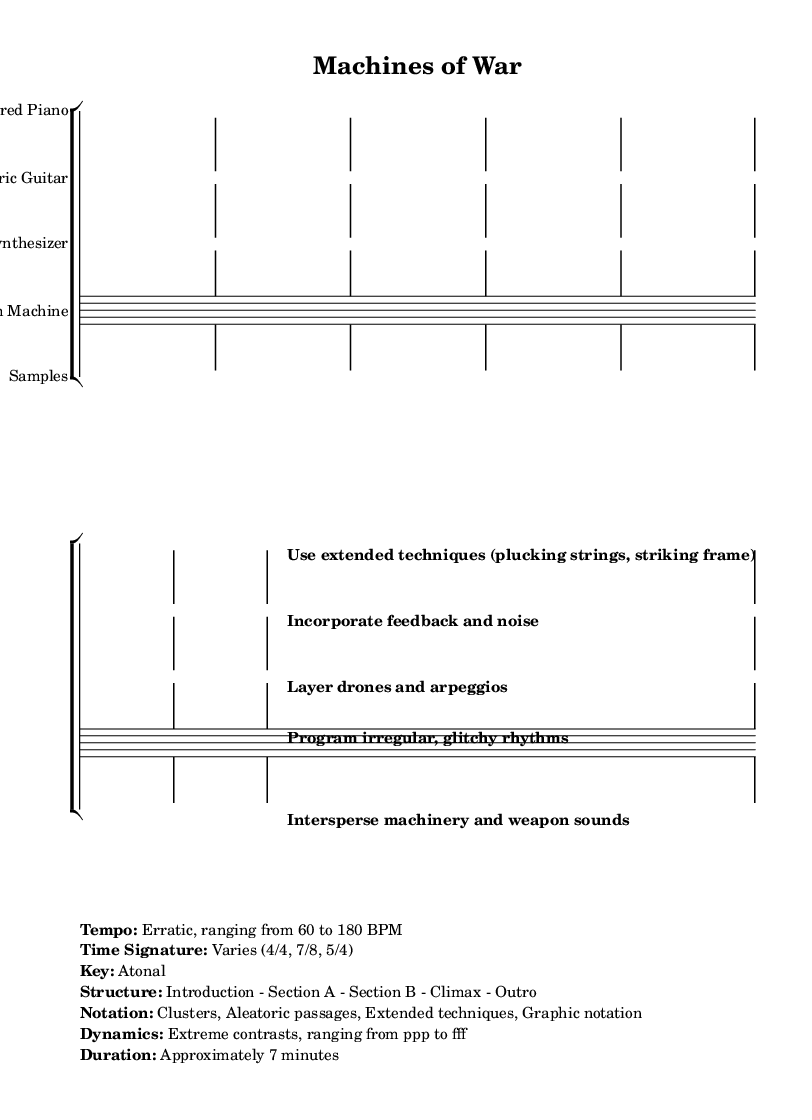What is the tempo of this music? The tempo is described as erratic, ranging from 60 to 180 BPM, indicating that the speeds vary unpredictably throughout the piece.
Answer: Erratic, ranging from 60 to 180 BPM What is the time signature used in this music? The time signature is noted as varying, specifically including 4/4, 7/8, and 5/4, allowing for multiple rhythmic interpretations throughout the piece.
Answer: Varies (4/4, 7/8, 5/4) What is the key signature of this composition? The piece is stated to be atonal, meaning it does not adhere to a specific key, which is typical in experimental or avant-garde music.
Answer: Atonal What type of dynamics are employed in this music? The dynamics range is specified as extreme contrasts, from ppp (pianississimo) to fff (fortississimo), which suggests a broad range of loudness and intensity intended to evoke strong emotional responses.
Answer: Extreme contrasts, ranging from ppp to fff What unique notation styles are used in this composition? The notation includes clusters, aleatoric passages, extended techniques, and graphic notation, showcasing the experimental nature and the emphasis on non-traditional methods of score interpretation.
Answer: Clusters, Aleatoric passages, Extended techniques, Graphic notation What should the drummer program in this piece? The text indicates that the drum machine should program irregular, glitchy rhythms, which align with the experimental theme and enhance the piece's mechanical sounds.
Answer: Program irregular, glitchy rhythms What are the extended techniques suggested for the Prepared Piano? The score suggests using extended techniques such as plucking strings and striking the frame of the piano, which are unconventional methods to produce unique sounds.
Answer: Use extended techniques (plucking strings, striking frame) 